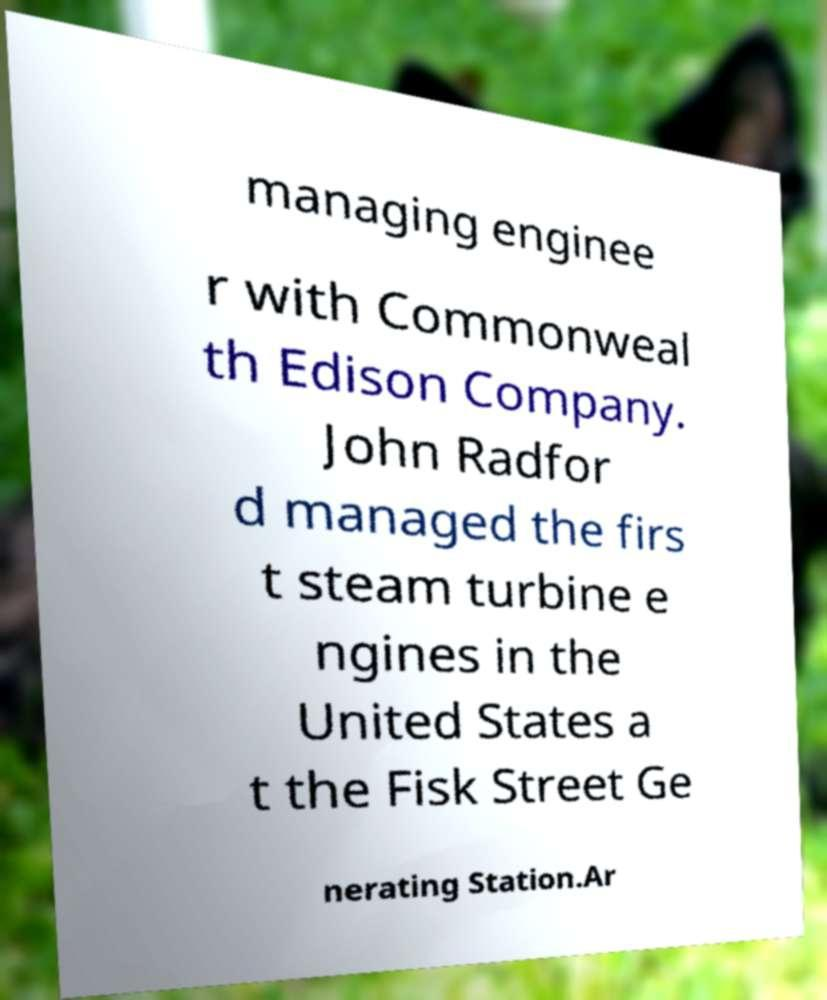Could you extract and type out the text from this image? managing enginee r with Commonweal th Edison Company. John Radfor d managed the firs t steam turbine e ngines in the United States a t the Fisk Street Ge nerating Station.Ar 